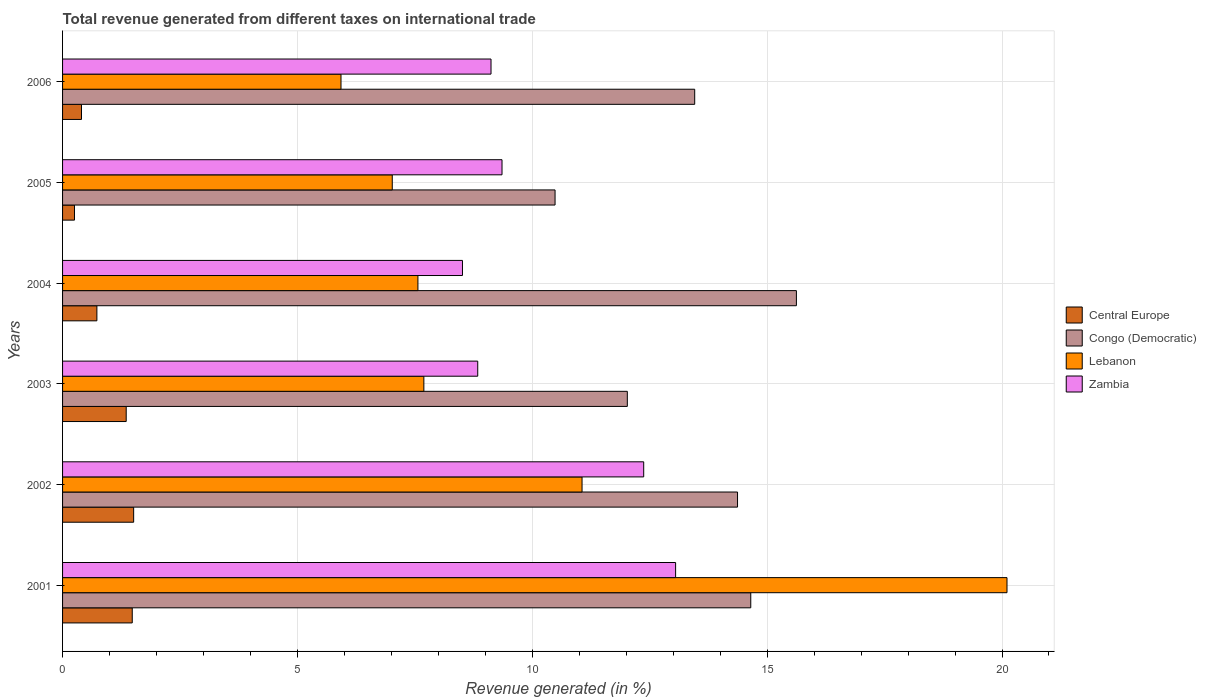How many different coloured bars are there?
Your response must be concise. 4. How many groups of bars are there?
Your answer should be very brief. 6. How many bars are there on the 6th tick from the top?
Offer a very short reply. 4. What is the label of the 5th group of bars from the top?
Ensure brevity in your answer.  2002. What is the total revenue generated in Congo (Democratic) in 2002?
Offer a very short reply. 14.37. Across all years, what is the maximum total revenue generated in Central Europe?
Provide a short and direct response. 1.51. Across all years, what is the minimum total revenue generated in Central Europe?
Your response must be concise. 0.25. In which year was the total revenue generated in Zambia minimum?
Make the answer very short. 2004. What is the total total revenue generated in Central Europe in the graph?
Ensure brevity in your answer.  5.74. What is the difference between the total revenue generated in Congo (Democratic) in 2002 and that in 2003?
Your answer should be very brief. 2.35. What is the difference between the total revenue generated in Congo (Democratic) in 2006 and the total revenue generated in Central Europe in 2005?
Offer a very short reply. 13.2. What is the average total revenue generated in Lebanon per year?
Your response must be concise. 9.9. In the year 2004, what is the difference between the total revenue generated in Lebanon and total revenue generated in Zambia?
Keep it short and to the point. -0.95. In how many years, is the total revenue generated in Lebanon greater than 15 %?
Make the answer very short. 1. What is the ratio of the total revenue generated in Lebanon in 2005 to that in 2006?
Your response must be concise. 1.18. Is the difference between the total revenue generated in Lebanon in 2002 and 2003 greater than the difference between the total revenue generated in Zambia in 2002 and 2003?
Your response must be concise. No. What is the difference between the highest and the second highest total revenue generated in Central Europe?
Give a very brief answer. 0.03. What is the difference between the highest and the lowest total revenue generated in Zambia?
Provide a succinct answer. 4.54. In how many years, is the total revenue generated in Zambia greater than the average total revenue generated in Zambia taken over all years?
Give a very brief answer. 2. Is the sum of the total revenue generated in Congo (Democratic) in 2002 and 2006 greater than the maximum total revenue generated in Central Europe across all years?
Make the answer very short. Yes. What does the 1st bar from the top in 2006 represents?
Ensure brevity in your answer.  Zambia. What does the 3rd bar from the bottom in 2006 represents?
Make the answer very short. Lebanon. How many years are there in the graph?
Your answer should be very brief. 6. Are the values on the major ticks of X-axis written in scientific E-notation?
Provide a short and direct response. No. Does the graph contain any zero values?
Your answer should be compact. No. Does the graph contain grids?
Offer a very short reply. Yes. Where does the legend appear in the graph?
Provide a succinct answer. Center right. How many legend labels are there?
Offer a very short reply. 4. How are the legend labels stacked?
Give a very brief answer. Vertical. What is the title of the graph?
Ensure brevity in your answer.  Total revenue generated from different taxes on international trade. Does "Philippines" appear as one of the legend labels in the graph?
Your answer should be very brief. No. What is the label or title of the X-axis?
Keep it short and to the point. Revenue generated (in %). What is the label or title of the Y-axis?
Keep it short and to the point. Years. What is the Revenue generated (in %) in Central Europe in 2001?
Your answer should be compact. 1.48. What is the Revenue generated (in %) of Congo (Democratic) in 2001?
Make the answer very short. 14.65. What is the Revenue generated (in %) of Lebanon in 2001?
Your answer should be compact. 20.11. What is the Revenue generated (in %) in Zambia in 2001?
Provide a short and direct response. 13.05. What is the Revenue generated (in %) in Central Europe in 2002?
Provide a succinct answer. 1.51. What is the Revenue generated (in %) in Congo (Democratic) in 2002?
Provide a succinct answer. 14.37. What is the Revenue generated (in %) of Lebanon in 2002?
Your answer should be very brief. 11.06. What is the Revenue generated (in %) of Zambia in 2002?
Your response must be concise. 12.37. What is the Revenue generated (in %) in Central Europe in 2003?
Provide a short and direct response. 1.35. What is the Revenue generated (in %) of Congo (Democratic) in 2003?
Provide a succinct answer. 12.02. What is the Revenue generated (in %) of Lebanon in 2003?
Provide a succinct answer. 7.69. What is the Revenue generated (in %) of Zambia in 2003?
Provide a succinct answer. 8.84. What is the Revenue generated (in %) in Central Europe in 2004?
Give a very brief answer. 0.73. What is the Revenue generated (in %) in Congo (Democratic) in 2004?
Offer a terse response. 15.62. What is the Revenue generated (in %) in Lebanon in 2004?
Your answer should be very brief. 7.57. What is the Revenue generated (in %) in Zambia in 2004?
Make the answer very short. 8.51. What is the Revenue generated (in %) of Central Europe in 2005?
Keep it short and to the point. 0.25. What is the Revenue generated (in %) of Congo (Democratic) in 2005?
Ensure brevity in your answer.  10.48. What is the Revenue generated (in %) in Lebanon in 2005?
Keep it short and to the point. 7.02. What is the Revenue generated (in %) in Zambia in 2005?
Offer a very short reply. 9.36. What is the Revenue generated (in %) of Central Europe in 2006?
Offer a very short reply. 0.4. What is the Revenue generated (in %) in Congo (Democratic) in 2006?
Make the answer very short. 13.46. What is the Revenue generated (in %) in Lebanon in 2006?
Offer a terse response. 5.93. What is the Revenue generated (in %) of Zambia in 2006?
Provide a short and direct response. 9.12. Across all years, what is the maximum Revenue generated (in %) of Central Europe?
Offer a terse response. 1.51. Across all years, what is the maximum Revenue generated (in %) of Congo (Democratic)?
Ensure brevity in your answer.  15.62. Across all years, what is the maximum Revenue generated (in %) of Lebanon?
Your answer should be compact. 20.11. Across all years, what is the maximum Revenue generated (in %) of Zambia?
Your answer should be very brief. 13.05. Across all years, what is the minimum Revenue generated (in %) in Central Europe?
Offer a terse response. 0.25. Across all years, what is the minimum Revenue generated (in %) of Congo (Democratic)?
Keep it short and to the point. 10.48. Across all years, what is the minimum Revenue generated (in %) in Lebanon?
Keep it short and to the point. 5.93. Across all years, what is the minimum Revenue generated (in %) of Zambia?
Ensure brevity in your answer.  8.51. What is the total Revenue generated (in %) of Central Europe in the graph?
Your response must be concise. 5.74. What is the total Revenue generated (in %) of Congo (Democratic) in the graph?
Your answer should be very brief. 80.61. What is the total Revenue generated (in %) in Lebanon in the graph?
Keep it short and to the point. 59.37. What is the total Revenue generated (in %) of Zambia in the graph?
Provide a short and direct response. 61.25. What is the difference between the Revenue generated (in %) of Central Europe in 2001 and that in 2002?
Keep it short and to the point. -0.03. What is the difference between the Revenue generated (in %) of Congo (Democratic) in 2001 and that in 2002?
Provide a short and direct response. 0.28. What is the difference between the Revenue generated (in %) of Lebanon in 2001 and that in 2002?
Make the answer very short. 9.05. What is the difference between the Revenue generated (in %) in Zambia in 2001 and that in 2002?
Make the answer very short. 0.68. What is the difference between the Revenue generated (in %) of Central Europe in 2001 and that in 2003?
Make the answer very short. 0.13. What is the difference between the Revenue generated (in %) of Congo (Democratic) in 2001 and that in 2003?
Provide a short and direct response. 2.63. What is the difference between the Revenue generated (in %) of Lebanon in 2001 and that in 2003?
Give a very brief answer. 12.41. What is the difference between the Revenue generated (in %) in Zambia in 2001 and that in 2003?
Your answer should be compact. 4.21. What is the difference between the Revenue generated (in %) in Central Europe in 2001 and that in 2004?
Offer a very short reply. 0.75. What is the difference between the Revenue generated (in %) of Congo (Democratic) in 2001 and that in 2004?
Provide a short and direct response. -0.97. What is the difference between the Revenue generated (in %) in Lebanon in 2001 and that in 2004?
Keep it short and to the point. 12.54. What is the difference between the Revenue generated (in %) in Zambia in 2001 and that in 2004?
Give a very brief answer. 4.54. What is the difference between the Revenue generated (in %) of Central Europe in 2001 and that in 2005?
Offer a terse response. 1.23. What is the difference between the Revenue generated (in %) of Congo (Democratic) in 2001 and that in 2005?
Your answer should be very brief. 4.17. What is the difference between the Revenue generated (in %) in Lebanon in 2001 and that in 2005?
Keep it short and to the point. 13.09. What is the difference between the Revenue generated (in %) of Zambia in 2001 and that in 2005?
Ensure brevity in your answer.  3.7. What is the difference between the Revenue generated (in %) in Central Europe in 2001 and that in 2006?
Your answer should be compact. 1.08. What is the difference between the Revenue generated (in %) of Congo (Democratic) in 2001 and that in 2006?
Offer a terse response. 1.19. What is the difference between the Revenue generated (in %) of Lebanon in 2001 and that in 2006?
Provide a succinct answer. 14.18. What is the difference between the Revenue generated (in %) in Zambia in 2001 and that in 2006?
Offer a terse response. 3.93. What is the difference between the Revenue generated (in %) of Central Europe in 2002 and that in 2003?
Make the answer very short. 0.16. What is the difference between the Revenue generated (in %) in Congo (Democratic) in 2002 and that in 2003?
Ensure brevity in your answer.  2.35. What is the difference between the Revenue generated (in %) of Lebanon in 2002 and that in 2003?
Make the answer very short. 3.37. What is the difference between the Revenue generated (in %) of Zambia in 2002 and that in 2003?
Your answer should be compact. 3.53. What is the difference between the Revenue generated (in %) of Central Europe in 2002 and that in 2004?
Your answer should be very brief. 0.78. What is the difference between the Revenue generated (in %) in Congo (Democratic) in 2002 and that in 2004?
Offer a very short reply. -1.25. What is the difference between the Revenue generated (in %) of Lebanon in 2002 and that in 2004?
Offer a very short reply. 3.49. What is the difference between the Revenue generated (in %) in Zambia in 2002 and that in 2004?
Make the answer very short. 3.86. What is the difference between the Revenue generated (in %) in Central Europe in 2002 and that in 2005?
Give a very brief answer. 1.26. What is the difference between the Revenue generated (in %) in Congo (Democratic) in 2002 and that in 2005?
Provide a succinct answer. 3.88. What is the difference between the Revenue generated (in %) in Lebanon in 2002 and that in 2005?
Offer a terse response. 4.04. What is the difference between the Revenue generated (in %) of Zambia in 2002 and that in 2005?
Give a very brief answer. 3.02. What is the difference between the Revenue generated (in %) of Central Europe in 2002 and that in 2006?
Your answer should be very brief. 1.11. What is the difference between the Revenue generated (in %) in Congo (Democratic) in 2002 and that in 2006?
Make the answer very short. 0.91. What is the difference between the Revenue generated (in %) in Lebanon in 2002 and that in 2006?
Ensure brevity in your answer.  5.13. What is the difference between the Revenue generated (in %) of Zambia in 2002 and that in 2006?
Offer a terse response. 3.25. What is the difference between the Revenue generated (in %) in Central Europe in 2003 and that in 2004?
Your response must be concise. 0.62. What is the difference between the Revenue generated (in %) of Congo (Democratic) in 2003 and that in 2004?
Offer a terse response. -3.6. What is the difference between the Revenue generated (in %) in Lebanon in 2003 and that in 2004?
Ensure brevity in your answer.  0.13. What is the difference between the Revenue generated (in %) of Zambia in 2003 and that in 2004?
Your answer should be compact. 0.33. What is the difference between the Revenue generated (in %) of Central Europe in 2003 and that in 2005?
Your answer should be compact. 1.1. What is the difference between the Revenue generated (in %) of Congo (Democratic) in 2003 and that in 2005?
Offer a terse response. 1.54. What is the difference between the Revenue generated (in %) of Lebanon in 2003 and that in 2005?
Give a very brief answer. 0.67. What is the difference between the Revenue generated (in %) of Zambia in 2003 and that in 2005?
Your answer should be compact. -0.52. What is the difference between the Revenue generated (in %) of Central Europe in 2003 and that in 2006?
Your answer should be compact. 0.95. What is the difference between the Revenue generated (in %) in Congo (Democratic) in 2003 and that in 2006?
Make the answer very short. -1.43. What is the difference between the Revenue generated (in %) of Lebanon in 2003 and that in 2006?
Keep it short and to the point. 1.76. What is the difference between the Revenue generated (in %) in Zambia in 2003 and that in 2006?
Your response must be concise. -0.28. What is the difference between the Revenue generated (in %) of Central Europe in 2004 and that in 2005?
Ensure brevity in your answer.  0.48. What is the difference between the Revenue generated (in %) in Congo (Democratic) in 2004 and that in 2005?
Give a very brief answer. 5.14. What is the difference between the Revenue generated (in %) of Lebanon in 2004 and that in 2005?
Your response must be concise. 0.55. What is the difference between the Revenue generated (in %) of Zambia in 2004 and that in 2005?
Offer a very short reply. -0.84. What is the difference between the Revenue generated (in %) of Central Europe in 2004 and that in 2006?
Keep it short and to the point. 0.33. What is the difference between the Revenue generated (in %) of Congo (Democratic) in 2004 and that in 2006?
Your response must be concise. 2.17. What is the difference between the Revenue generated (in %) of Lebanon in 2004 and that in 2006?
Ensure brevity in your answer.  1.64. What is the difference between the Revenue generated (in %) of Zambia in 2004 and that in 2006?
Keep it short and to the point. -0.61. What is the difference between the Revenue generated (in %) of Central Europe in 2005 and that in 2006?
Your answer should be very brief. -0.15. What is the difference between the Revenue generated (in %) in Congo (Democratic) in 2005 and that in 2006?
Your answer should be compact. -2.97. What is the difference between the Revenue generated (in %) of Lebanon in 2005 and that in 2006?
Offer a very short reply. 1.09. What is the difference between the Revenue generated (in %) of Zambia in 2005 and that in 2006?
Provide a short and direct response. 0.23. What is the difference between the Revenue generated (in %) in Central Europe in 2001 and the Revenue generated (in %) in Congo (Democratic) in 2002?
Provide a short and direct response. -12.89. What is the difference between the Revenue generated (in %) in Central Europe in 2001 and the Revenue generated (in %) in Lebanon in 2002?
Offer a terse response. -9.58. What is the difference between the Revenue generated (in %) of Central Europe in 2001 and the Revenue generated (in %) of Zambia in 2002?
Your answer should be very brief. -10.89. What is the difference between the Revenue generated (in %) in Congo (Democratic) in 2001 and the Revenue generated (in %) in Lebanon in 2002?
Your answer should be very brief. 3.59. What is the difference between the Revenue generated (in %) in Congo (Democratic) in 2001 and the Revenue generated (in %) in Zambia in 2002?
Offer a terse response. 2.28. What is the difference between the Revenue generated (in %) in Lebanon in 2001 and the Revenue generated (in %) in Zambia in 2002?
Ensure brevity in your answer.  7.73. What is the difference between the Revenue generated (in %) in Central Europe in 2001 and the Revenue generated (in %) in Congo (Democratic) in 2003?
Give a very brief answer. -10.54. What is the difference between the Revenue generated (in %) in Central Europe in 2001 and the Revenue generated (in %) in Lebanon in 2003?
Offer a very short reply. -6.21. What is the difference between the Revenue generated (in %) of Central Europe in 2001 and the Revenue generated (in %) of Zambia in 2003?
Make the answer very short. -7.36. What is the difference between the Revenue generated (in %) of Congo (Democratic) in 2001 and the Revenue generated (in %) of Lebanon in 2003?
Your answer should be compact. 6.96. What is the difference between the Revenue generated (in %) of Congo (Democratic) in 2001 and the Revenue generated (in %) of Zambia in 2003?
Offer a terse response. 5.81. What is the difference between the Revenue generated (in %) in Lebanon in 2001 and the Revenue generated (in %) in Zambia in 2003?
Your answer should be compact. 11.27. What is the difference between the Revenue generated (in %) of Central Europe in 2001 and the Revenue generated (in %) of Congo (Democratic) in 2004?
Give a very brief answer. -14.14. What is the difference between the Revenue generated (in %) in Central Europe in 2001 and the Revenue generated (in %) in Lebanon in 2004?
Give a very brief answer. -6.08. What is the difference between the Revenue generated (in %) of Central Europe in 2001 and the Revenue generated (in %) of Zambia in 2004?
Provide a short and direct response. -7.03. What is the difference between the Revenue generated (in %) in Congo (Democratic) in 2001 and the Revenue generated (in %) in Lebanon in 2004?
Offer a terse response. 7.09. What is the difference between the Revenue generated (in %) of Congo (Democratic) in 2001 and the Revenue generated (in %) of Zambia in 2004?
Offer a terse response. 6.14. What is the difference between the Revenue generated (in %) of Lebanon in 2001 and the Revenue generated (in %) of Zambia in 2004?
Offer a very short reply. 11.59. What is the difference between the Revenue generated (in %) of Central Europe in 2001 and the Revenue generated (in %) of Congo (Democratic) in 2005?
Your response must be concise. -9. What is the difference between the Revenue generated (in %) in Central Europe in 2001 and the Revenue generated (in %) in Lebanon in 2005?
Your answer should be very brief. -5.54. What is the difference between the Revenue generated (in %) of Central Europe in 2001 and the Revenue generated (in %) of Zambia in 2005?
Your response must be concise. -7.87. What is the difference between the Revenue generated (in %) of Congo (Democratic) in 2001 and the Revenue generated (in %) of Lebanon in 2005?
Your answer should be compact. 7.63. What is the difference between the Revenue generated (in %) of Congo (Democratic) in 2001 and the Revenue generated (in %) of Zambia in 2005?
Make the answer very short. 5.3. What is the difference between the Revenue generated (in %) of Lebanon in 2001 and the Revenue generated (in %) of Zambia in 2005?
Offer a very short reply. 10.75. What is the difference between the Revenue generated (in %) in Central Europe in 2001 and the Revenue generated (in %) in Congo (Democratic) in 2006?
Ensure brevity in your answer.  -11.97. What is the difference between the Revenue generated (in %) in Central Europe in 2001 and the Revenue generated (in %) in Lebanon in 2006?
Keep it short and to the point. -4.44. What is the difference between the Revenue generated (in %) of Central Europe in 2001 and the Revenue generated (in %) of Zambia in 2006?
Keep it short and to the point. -7.64. What is the difference between the Revenue generated (in %) in Congo (Democratic) in 2001 and the Revenue generated (in %) in Lebanon in 2006?
Offer a terse response. 8.72. What is the difference between the Revenue generated (in %) of Congo (Democratic) in 2001 and the Revenue generated (in %) of Zambia in 2006?
Give a very brief answer. 5.53. What is the difference between the Revenue generated (in %) in Lebanon in 2001 and the Revenue generated (in %) in Zambia in 2006?
Provide a succinct answer. 10.99. What is the difference between the Revenue generated (in %) in Central Europe in 2002 and the Revenue generated (in %) in Congo (Democratic) in 2003?
Make the answer very short. -10.51. What is the difference between the Revenue generated (in %) of Central Europe in 2002 and the Revenue generated (in %) of Lebanon in 2003?
Your answer should be compact. -6.18. What is the difference between the Revenue generated (in %) in Central Europe in 2002 and the Revenue generated (in %) in Zambia in 2003?
Make the answer very short. -7.33. What is the difference between the Revenue generated (in %) in Congo (Democratic) in 2002 and the Revenue generated (in %) in Lebanon in 2003?
Provide a short and direct response. 6.68. What is the difference between the Revenue generated (in %) in Congo (Democratic) in 2002 and the Revenue generated (in %) in Zambia in 2003?
Offer a terse response. 5.53. What is the difference between the Revenue generated (in %) of Lebanon in 2002 and the Revenue generated (in %) of Zambia in 2003?
Offer a very short reply. 2.22. What is the difference between the Revenue generated (in %) in Central Europe in 2002 and the Revenue generated (in %) in Congo (Democratic) in 2004?
Keep it short and to the point. -14.11. What is the difference between the Revenue generated (in %) in Central Europe in 2002 and the Revenue generated (in %) in Lebanon in 2004?
Your answer should be compact. -6.05. What is the difference between the Revenue generated (in %) in Central Europe in 2002 and the Revenue generated (in %) in Zambia in 2004?
Keep it short and to the point. -7. What is the difference between the Revenue generated (in %) in Congo (Democratic) in 2002 and the Revenue generated (in %) in Lebanon in 2004?
Keep it short and to the point. 6.8. What is the difference between the Revenue generated (in %) of Congo (Democratic) in 2002 and the Revenue generated (in %) of Zambia in 2004?
Your answer should be compact. 5.86. What is the difference between the Revenue generated (in %) of Lebanon in 2002 and the Revenue generated (in %) of Zambia in 2004?
Provide a succinct answer. 2.55. What is the difference between the Revenue generated (in %) of Central Europe in 2002 and the Revenue generated (in %) of Congo (Democratic) in 2005?
Keep it short and to the point. -8.97. What is the difference between the Revenue generated (in %) of Central Europe in 2002 and the Revenue generated (in %) of Lebanon in 2005?
Ensure brevity in your answer.  -5.51. What is the difference between the Revenue generated (in %) of Central Europe in 2002 and the Revenue generated (in %) of Zambia in 2005?
Your response must be concise. -7.84. What is the difference between the Revenue generated (in %) of Congo (Democratic) in 2002 and the Revenue generated (in %) of Lebanon in 2005?
Your answer should be very brief. 7.35. What is the difference between the Revenue generated (in %) in Congo (Democratic) in 2002 and the Revenue generated (in %) in Zambia in 2005?
Provide a succinct answer. 5.01. What is the difference between the Revenue generated (in %) of Lebanon in 2002 and the Revenue generated (in %) of Zambia in 2005?
Offer a terse response. 1.7. What is the difference between the Revenue generated (in %) in Central Europe in 2002 and the Revenue generated (in %) in Congo (Democratic) in 2006?
Your answer should be compact. -11.94. What is the difference between the Revenue generated (in %) of Central Europe in 2002 and the Revenue generated (in %) of Lebanon in 2006?
Give a very brief answer. -4.41. What is the difference between the Revenue generated (in %) of Central Europe in 2002 and the Revenue generated (in %) of Zambia in 2006?
Your answer should be very brief. -7.61. What is the difference between the Revenue generated (in %) in Congo (Democratic) in 2002 and the Revenue generated (in %) in Lebanon in 2006?
Offer a very short reply. 8.44. What is the difference between the Revenue generated (in %) of Congo (Democratic) in 2002 and the Revenue generated (in %) of Zambia in 2006?
Your answer should be very brief. 5.25. What is the difference between the Revenue generated (in %) of Lebanon in 2002 and the Revenue generated (in %) of Zambia in 2006?
Your answer should be very brief. 1.94. What is the difference between the Revenue generated (in %) of Central Europe in 2003 and the Revenue generated (in %) of Congo (Democratic) in 2004?
Your answer should be very brief. -14.27. What is the difference between the Revenue generated (in %) of Central Europe in 2003 and the Revenue generated (in %) of Lebanon in 2004?
Keep it short and to the point. -6.21. What is the difference between the Revenue generated (in %) in Central Europe in 2003 and the Revenue generated (in %) in Zambia in 2004?
Give a very brief answer. -7.16. What is the difference between the Revenue generated (in %) of Congo (Democratic) in 2003 and the Revenue generated (in %) of Lebanon in 2004?
Provide a short and direct response. 4.46. What is the difference between the Revenue generated (in %) of Congo (Democratic) in 2003 and the Revenue generated (in %) of Zambia in 2004?
Provide a succinct answer. 3.51. What is the difference between the Revenue generated (in %) of Lebanon in 2003 and the Revenue generated (in %) of Zambia in 2004?
Offer a terse response. -0.82. What is the difference between the Revenue generated (in %) of Central Europe in 2003 and the Revenue generated (in %) of Congo (Democratic) in 2005?
Your response must be concise. -9.13. What is the difference between the Revenue generated (in %) in Central Europe in 2003 and the Revenue generated (in %) in Lebanon in 2005?
Give a very brief answer. -5.66. What is the difference between the Revenue generated (in %) of Central Europe in 2003 and the Revenue generated (in %) of Zambia in 2005?
Provide a short and direct response. -8. What is the difference between the Revenue generated (in %) in Congo (Democratic) in 2003 and the Revenue generated (in %) in Lebanon in 2005?
Give a very brief answer. 5. What is the difference between the Revenue generated (in %) in Congo (Democratic) in 2003 and the Revenue generated (in %) in Zambia in 2005?
Provide a short and direct response. 2.67. What is the difference between the Revenue generated (in %) in Lebanon in 2003 and the Revenue generated (in %) in Zambia in 2005?
Give a very brief answer. -1.66. What is the difference between the Revenue generated (in %) of Central Europe in 2003 and the Revenue generated (in %) of Congo (Democratic) in 2006?
Your answer should be compact. -12.1. What is the difference between the Revenue generated (in %) of Central Europe in 2003 and the Revenue generated (in %) of Lebanon in 2006?
Provide a short and direct response. -4.57. What is the difference between the Revenue generated (in %) of Central Europe in 2003 and the Revenue generated (in %) of Zambia in 2006?
Make the answer very short. -7.77. What is the difference between the Revenue generated (in %) of Congo (Democratic) in 2003 and the Revenue generated (in %) of Lebanon in 2006?
Give a very brief answer. 6.1. What is the difference between the Revenue generated (in %) in Congo (Democratic) in 2003 and the Revenue generated (in %) in Zambia in 2006?
Your answer should be very brief. 2.9. What is the difference between the Revenue generated (in %) of Lebanon in 2003 and the Revenue generated (in %) of Zambia in 2006?
Offer a very short reply. -1.43. What is the difference between the Revenue generated (in %) of Central Europe in 2004 and the Revenue generated (in %) of Congo (Democratic) in 2005?
Ensure brevity in your answer.  -9.75. What is the difference between the Revenue generated (in %) in Central Europe in 2004 and the Revenue generated (in %) in Lebanon in 2005?
Ensure brevity in your answer.  -6.29. What is the difference between the Revenue generated (in %) of Central Europe in 2004 and the Revenue generated (in %) of Zambia in 2005?
Keep it short and to the point. -8.62. What is the difference between the Revenue generated (in %) in Congo (Democratic) in 2004 and the Revenue generated (in %) in Lebanon in 2005?
Keep it short and to the point. 8.6. What is the difference between the Revenue generated (in %) of Congo (Democratic) in 2004 and the Revenue generated (in %) of Zambia in 2005?
Your answer should be very brief. 6.27. What is the difference between the Revenue generated (in %) in Lebanon in 2004 and the Revenue generated (in %) in Zambia in 2005?
Offer a very short reply. -1.79. What is the difference between the Revenue generated (in %) of Central Europe in 2004 and the Revenue generated (in %) of Congo (Democratic) in 2006?
Your answer should be very brief. -12.73. What is the difference between the Revenue generated (in %) in Central Europe in 2004 and the Revenue generated (in %) in Lebanon in 2006?
Provide a succinct answer. -5.2. What is the difference between the Revenue generated (in %) of Central Europe in 2004 and the Revenue generated (in %) of Zambia in 2006?
Give a very brief answer. -8.39. What is the difference between the Revenue generated (in %) of Congo (Democratic) in 2004 and the Revenue generated (in %) of Lebanon in 2006?
Provide a short and direct response. 9.7. What is the difference between the Revenue generated (in %) in Congo (Democratic) in 2004 and the Revenue generated (in %) in Zambia in 2006?
Provide a short and direct response. 6.5. What is the difference between the Revenue generated (in %) of Lebanon in 2004 and the Revenue generated (in %) of Zambia in 2006?
Keep it short and to the point. -1.56. What is the difference between the Revenue generated (in %) in Central Europe in 2005 and the Revenue generated (in %) in Congo (Democratic) in 2006?
Your answer should be compact. -13.2. What is the difference between the Revenue generated (in %) in Central Europe in 2005 and the Revenue generated (in %) in Lebanon in 2006?
Offer a very short reply. -5.67. What is the difference between the Revenue generated (in %) in Central Europe in 2005 and the Revenue generated (in %) in Zambia in 2006?
Ensure brevity in your answer.  -8.87. What is the difference between the Revenue generated (in %) in Congo (Democratic) in 2005 and the Revenue generated (in %) in Lebanon in 2006?
Your answer should be very brief. 4.56. What is the difference between the Revenue generated (in %) in Congo (Democratic) in 2005 and the Revenue generated (in %) in Zambia in 2006?
Ensure brevity in your answer.  1.36. What is the difference between the Revenue generated (in %) of Lebanon in 2005 and the Revenue generated (in %) of Zambia in 2006?
Provide a succinct answer. -2.1. What is the average Revenue generated (in %) of Central Europe per year?
Provide a succinct answer. 0.96. What is the average Revenue generated (in %) of Congo (Democratic) per year?
Provide a succinct answer. 13.44. What is the average Revenue generated (in %) in Lebanon per year?
Your answer should be compact. 9.89. What is the average Revenue generated (in %) in Zambia per year?
Your answer should be very brief. 10.21. In the year 2001, what is the difference between the Revenue generated (in %) of Central Europe and Revenue generated (in %) of Congo (Democratic)?
Ensure brevity in your answer.  -13.17. In the year 2001, what is the difference between the Revenue generated (in %) of Central Europe and Revenue generated (in %) of Lebanon?
Your answer should be compact. -18.62. In the year 2001, what is the difference between the Revenue generated (in %) in Central Europe and Revenue generated (in %) in Zambia?
Make the answer very short. -11.57. In the year 2001, what is the difference between the Revenue generated (in %) of Congo (Democratic) and Revenue generated (in %) of Lebanon?
Offer a very short reply. -5.46. In the year 2001, what is the difference between the Revenue generated (in %) in Congo (Democratic) and Revenue generated (in %) in Zambia?
Make the answer very short. 1.6. In the year 2001, what is the difference between the Revenue generated (in %) of Lebanon and Revenue generated (in %) of Zambia?
Make the answer very short. 7.06. In the year 2002, what is the difference between the Revenue generated (in %) of Central Europe and Revenue generated (in %) of Congo (Democratic)?
Offer a very short reply. -12.86. In the year 2002, what is the difference between the Revenue generated (in %) in Central Europe and Revenue generated (in %) in Lebanon?
Give a very brief answer. -9.55. In the year 2002, what is the difference between the Revenue generated (in %) of Central Europe and Revenue generated (in %) of Zambia?
Your answer should be compact. -10.86. In the year 2002, what is the difference between the Revenue generated (in %) of Congo (Democratic) and Revenue generated (in %) of Lebanon?
Offer a terse response. 3.31. In the year 2002, what is the difference between the Revenue generated (in %) in Congo (Democratic) and Revenue generated (in %) in Zambia?
Ensure brevity in your answer.  2. In the year 2002, what is the difference between the Revenue generated (in %) of Lebanon and Revenue generated (in %) of Zambia?
Keep it short and to the point. -1.31. In the year 2003, what is the difference between the Revenue generated (in %) of Central Europe and Revenue generated (in %) of Congo (Democratic)?
Provide a short and direct response. -10.67. In the year 2003, what is the difference between the Revenue generated (in %) of Central Europe and Revenue generated (in %) of Lebanon?
Provide a short and direct response. -6.34. In the year 2003, what is the difference between the Revenue generated (in %) in Central Europe and Revenue generated (in %) in Zambia?
Provide a succinct answer. -7.48. In the year 2003, what is the difference between the Revenue generated (in %) in Congo (Democratic) and Revenue generated (in %) in Lebanon?
Your answer should be very brief. 4.33. In the year 2003, what is the difference between the Revenue generated (in %) in Congo (Democratic) and Revenue generated (in %) in Zambia?
Keep it short and to the point. 3.18. In the year 2003, what is the difference between the Revenue generated (in %) in Lebanon and Revenue generated (in %) in Zambia?
Offer a terse response. -1.15. In the year 2004, what is the difference between the Revenue generated (in %) in Central Europe and Revenue generated (in %) in Congo (Democratic)?
Your response must be concise. -14.89. In the year 2004, what is the difference between the Revenue generated (in %) in Central Europe and Revenue generated (in %) in Lebanon?
Your answer should be compact. -6.83. In the year 2004, what is the difference between the Revenue generated (in %) of Central Europe and Revenue generated (in %) of Zambia?
Your response must be concise. -7.78. In the year 2004, what is the difference between the Revenue generated (in %) of Congo (Democratic) and Revenue generated (in %) of Lebanon?
Keep it short and to the point. 8.06. In the year 2004, what is the difference between the Revenue generated (in %) of Congo (Democratic) and Revenue generated (in %) of Zambia?
Ensure brevity in your answer.  7.11. In the year 2004, what is the difference between the Revenue generated (in %) in Lebanon and Revenue generated (in %) in Zambia?
Offer a very short reply. -0.95. In the year 2005, what is the difference between the Revenue generated (in %) in Central Europe and Revenue generated (in %) in Congo (Democratic)?
Make the answer very short. -10.23. In the year 2005, what is the difference between the Revenue generated (in %) in Central Europe and Revenue generated (in %) in Lebanon?
Ensure brevity in your answer.  -6.77. In the year 2005, what is the difference between the Revenue generated (in %) in Central Europe and Revenue generated (in %) in Zambia?
Give a very brief answer. -9.1. In the year 2005, what is the difference between the Revenue generated (in %) of Congo (Democratic) and Revenue generated (in %) of Lebanon?
Your response must be concise. 3.47. In the year 2005, what is the difference between the Revenue generated (in %) of Congo (Democratic) and Revenue generated (in %) of Zambia?
Offer a very short reply. 1.13. In the year 2005, what is the difference between the Revenue generated (in %) in Lebanon and Revenue generated (in %) in Zambia?
Give a very brief answer. -2.34. In the year 2006, what is the difference between the Revenue generated (in %) of Central Europe and Revenue generated (in %) of Congo (Democratic)?
Offer a terse response. -13.05. In the year 2006, what is the difference between the Revenue generated (in %) in Central Europe and Revenue generated (in %) in Lebanon?
Offer a very short reply. -5.52. In the year 2006, what is the difference between the Revenue generated (in %) of Central Europe and Revenue generated (in %) of Zambia?
Keep it short and to the point. -8.72. In the year 2006, what is the difference between the Revenue generated (in %) in Congo (Democratic) and Revenue generated (in %) in Lebanon?
Offer a very short reply. 7.53. In the year 2006, what is the difference between the Revenue generated (in %) of Congo (Democratic) and Revenue generated (in %) of Zambia?
Provide a short and direct response. 4.34. In the year 2006, what is the difference between the Revenue generated (in %) of Lebanon and Revenue generated (in %) of Zambia?
Offer a terse response. -3.19. What is the ratio of the Revenue generated (in %) of Central Europe in 2001 to that in 2002?
Make the answer very short. 0.98. What is the ratio of the Revenue generated (in %) in Congo (Democratic) in 2001 to that in 2002?
Provide a short and direct response. 1.02. What is the ratio of the Revenue generated (in %) in Lebanon in 2001 to that in 2002?
Your answer should be compact. 1.82. What is the ratio of the Revenue generated (in %) of Zambia in 2001 to that in 2002?
Make the answer very short. 1.05. What is the ratio of the Revenue generated (in %) of Central Europe in 2001 to that in 2003?
Your answer should be very brief. 1.1. What is the ratio of the Revenue generated (in %) of Congo (Democratic) in 2001 to that in 2003?
Provide a short and direct response. 1.22. What is the ratio of the Revenue generated (in %) of Lebanon in 2001 to that in 2003?
Your answer should be very brief. 2.61. What is the ratio of the Revenue generated (in %) of Zambia in 2001 to that in 2003?
Ensure brevity in your answer.  1.48. What is the ratio of the Revenue generated (in %) of Central Europe in 2001 to that in 2004?
Ensure brevity in your answer.  2.03. What is the ratio of the Revenue generated (in %) of Congo (Democratic) in 2001 to that in 2004?
Provide a short and direct response. 0.94. What is the ratio of the Revenue generated (in %) in Lebanon in 2001 to that in 2004?
Your answer should be compact. 2.66. What is the ratio of the Revenue generated (in %) of Zambia in 2001 to that in 2004?
Keep it short and to the point. 1.53. What is the ratio of the Revenue generated (in %) of Central Europe in 2001 to that in 2005?
Offer a terse response. 5.85. What is the ratio of the Revenue generated (in %) in Congo (Democratic) in 2001 to that in 2005?
Your answer should be very brief. 1.4. What is the ratio of the Revenue generated (in %) of Lebanon in 2001 to that in 2005?
Provide a short and direct response. 2.86. What is the ratio of the Revenue generated (in %) of Zambia in 2001 to that in 2005?
Your response must be concise. 1.4. What is the ratio of the Revenue generated (in %) of Central Europe in 2001 to that in 2006?
Give a very brief answer. 3.68. What is the ratio of the Revenue generated (in %) of Congo (Democratic) in 2001 to that in 2006?
Your answer should be compact. 1.09. What is the ratio of the Revenue generated (in %) of Lebanon in 2001 to that in 2006?
Ensure brevity in your answer.  3.39. What is the ratio of the Revenue generated (in %) of Zambia in 2001 to that in 2006?
Make the answer very short. 1.43. What is the ratio of the Revenue generated (in %) of Central Europe in 2002 to that in 2003?
Give a very brief answer. 1.12. What is the ratio of the Revenue generated (in %) of Congo (Democratic) in 2002 to that in 2003?
Make the answer very short. 1.2. What is the ratio of the Revenue generated (in %) of Lebanon in 2002 to that in 2003?
Offer a terse response. 1.44. What is the ratio of the Revenue generated (in %) of Zambia in 2002 to that in 2003?
Ensure brevity in your answer.  1.4. What is the ratio of the Revenue generated (in %) in Central Europe in 2002 to that in 2004?
Make the answer very short. 2.07. What is the ratio of the Revenue generated (in %) in Congo (Democratic) in 2002 to that in 2004?
Give a very brief answer. 0.92. What is the ratio of the Revenue generated (in %) of Lebanon in 2002 to that in 2004?
Provide a short and direct response. 1.46. What is the ratio of the Revenue generated (in %) in Zambia in 2002 to that in 2004?
Give a very brief answer. 1.45. What is the ratio of the Revenue generated (in %) of Central Europe in 2002 to that in 2005?
Ensure brevity in your answer.  5.97. What is the ratio of the Revenue generated (in %) of Congo (Democratic) in 2002 to that in 2005?
Give a very brief answer. 1.37. What is the ratio of the Revenue generated (in %) of Lebanon in 2002 to that in 2005?
Your response must be concise. 1.58. What is the ratio of the Revenue generated (in %) of Zambia in 2002 to that in 2005?
Offer a very short reply. 1.32. What is the ratio of the Revenue generated (in %) of Central Europe in 2002 to that in 2006?
Your answer should be compact. 3.75. What is the ratio of the Revenue generated (in %) of Congo (Democratic) in 2002 to that in 2006?
Your response must be concise. 1.07. What is the ratio of the Revenue generated (in %) in Lebanon in 2002 to that in 2006?
Ensure brevity in your answer.  1.87. What is the ratio of the Revenue generated (in %) in Zambia in 2002 to that in 2006?
Provide a succinct answer. 1.36. What is the ratio of the Revenue generated (in %) in Central Europe in 2003 to that in 2004?
Keep it short and to the point. 1.85. What is the ratio of the Revenue generated (in %) of Congo (Democratic) in 2003 to that in 2004?
Give a very brief answer. 0.77. What is the ratio of the Revenue generated (in %) in Lebanon in 2003 to that in 2004?
Ensure brevity in your answer.  1.02. What is the ratio of the Revenue generated (in %) in Zambia in 2003 to that in 2004?
Make the answer very short. 1.04. What is the ratio of the Revenue generated (in %) of Central Europe in 2003 to that in 2005?
Offer a very short reply. 5.34. What is the ratio of the Revenue generated (in %) of Congo (Democratic) in 2003 to that in 2005?
Make the answer very short. 1.15. What is the ratio of the Revenue generated (in %) in Lebanon in 2003 to that in 2005?
Provide a short and direct response. 1.1. What is the ratio of the Revenue generated (in %) of Zambia in 2003 to that in 2005?
Your answer should be compact. 0.94. What is the ratio of the Revenue generated (in %) in Central Europe in 2003 to that in 2006?
Offer a terse response. 3.36. What is the ratio of the Revenue generated (in %) in Congo (Democratic) in 2003 to that in 2006?
Provide a short and direct response. 0.89. What is the ratio of the Revenue generated (in %) in Lebanon in 2003 to that in 2006?
Your answer should be very brief. 1.3. What is the ratio of the Revenue generated (in %) in Central Europe in 2004 to that in 2005?
Ensure brevity in your answer.  2.88. What is the ratio of the Revenue generated (in %) of Congo (Democratic) in 2004 to that in 2005?
Keep it short and to the point. 1.49. What is the ratio of the Revenue generated (in %) in Lebanon in 2004 to that in 2005?
Provide a succinct answer. 1.08. What is the ratio of the Revenue generated (in %) in Zambia in 2004 to that in 2005?
Provide a succinct answer. 0.91. What is the ratio of the Revenue generated (in %) in Central Europe in 2004 to that in 2006?
Give a very brief answer. 1.81. What is the ratio of the Revenue generated (in %) in Congo (Democratic) in 2004 to that in 2006?
Provide a short and direct response. 1.16. What is the ratio of the Revenue generated (in %) in Lebanon in 2004 to that in 2006?
Offer a terse response. 1.28. What is the ratio of the Revenue generated (in %) of Zambia in 2004 to that in 2006?
Keep it short and to the point. 0.93. What is the ratio of the Revenue generated (in %) in Central Europe in 2005 to that in 2006?
Your answer should be compact. 0.63. What is the ratio of the Revenue generated (in %) in Congo (Democratic) in 2005 to that in 2006?
Your answer should be compact. 0.78. What is the ratio of the Revenue generated (in %) in Lebanon in 2005 to that in 2006?
Ensure brevity in your answer.  1.18. What is the ratio of the Revenue generated (in %) in Zambia in 2005 to that in 2006?
Your answer should be very brief. 1.03. What is the difference between the highest and the second highest Revenue generated (in %) in Central Europe?
Provide a succinct answer. 0.03. What is the difference between the highest and the second highest Revenue generated (in %) of Congo (Democratic)?
Ensure brevity in your answer.  0.97. What is the difference between the highest and the second highest Revenue generated (in %) in Lebanon?
Your answer should be compact. 9.05. What is the difference between the highest and the second highest Revenue generated (in %) in Zambia?
Offer a terse response. 0.68. What is the difference between the highest and the lowest Revenue generated (in %) in Central Europe?
Provide a short and direct response. 1.26. What is the difference between the highest and the lowest Revenue generated (in %) of Congo (Democratic)?
Ensure brevity in your answer.  5.14. What is the difference between the highest and the lowest Revenue generated (in %) of Lebanon?
Make the answer very short. 14.18. What is the difference between the highest and the lowest Revenue generated (in %) in Zambia?
Provide a succinct answer. 4.54. 